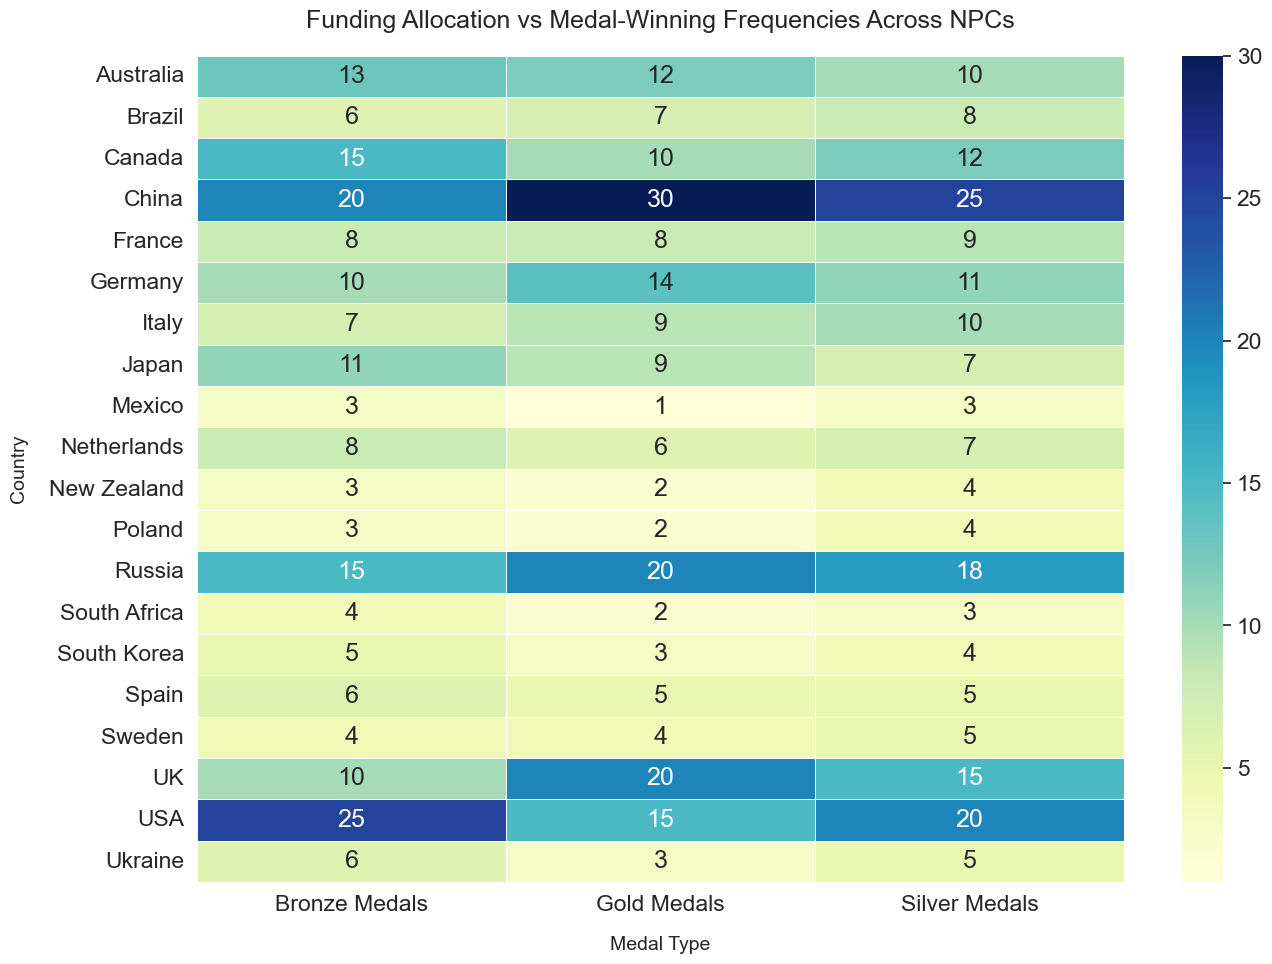Which country has the highest number of gold medals? Look at the row corresponding to "Gold Medals"; the country with the highest number in this column is China with 30 gold medals.
Answer: China Which countries have more than 20 million in funding but won fewer than 10 gold medals? Look at the "Funding (in Millions)" column and identify the countries with more than 20 million. Then check the "Gold Medals" column, filtering out countries with fewer than 10 gold medals. The countries that meet both criteria are Japan and France.
Answer: Japan, France What is the total number of medals won by USA? For the USA row, sum the counts of gold, silver, and bronze medals: 15 (gold) + 20 (silver) + 25 (bronze) = 60.
Answer: 60 Is there a noticeable pattern between the funding and the number of medals (gold, silver, bronze) a country wins? By visually comparing the rows and columns, it appears that countries with higher funding tend to have more medals across all types. This is noticeable in entries like China and USA, which have high funding and high medal counts.
Answer: Yes Which country has the least funding and how many bronze medals did they win? Look for the country with the minimum value in the "Funding (in Millions)" column, which is Mexico with 6 million. The corresponding number of bronze medals is 3.
Answer: Mexico, 3 How does the number of silver medals won by Russia compare to the number of silver medals won by Germany? Compare the number in the "Silver Medals" column for Russia and Germany: Russia has 18 silver medals and Germany has 11. Therefore, Russia has 7 more silver medals than Germany.
Answer: Russia has 7 more Which country has the highest number of medals per million dollars of funding? Calculate the total number of medals for each country, then divide by their funding. Compare these values: (USA: 60/50 = 1.2), (China: 75/70 ≈ 1.07), (UK: 45/45 = 1), (Canada: 37/30 ≈ 1.23), (Australia: 35/35 = 1), (Germany: 35/40 = 0.875), (Japan: 27/25 = 1.08), (Russia: 53/50 = 1.06), (Brazil: 21/20 = 1.05), (France: 25/25 = 1), (Netherlands: 21/18 ≈ 1.17), (Italy: 26/22 ≈ 1.18), (Spain: 16/15 = 1.07), (South Korea: 12/10 = 1.2), (Sweden: 13/12 ≈ 1.08), (New Zealand: 9/8 = 1.125), (Mexico: 7/6 ≈ 1.17), (South Africa: 9/9 = 1), (Ukraine: 14/11 ≈ 1.27), (Poland: 9/7 ≈ 1.29). The country with the highest value is Poland with ≈ 1.29 medals per million dollars.
Answer: Poland Which countries have the same number of bronze medals? Look for the same value in the "Bronze Medals" column. Countries with the same number of bronze medals are: USA and Japan (25); South Korea, Sweden, New Zealand, and Poland (3).
Answer: USA and Japan; South Korea, Sweden, New Zealand, Poland 